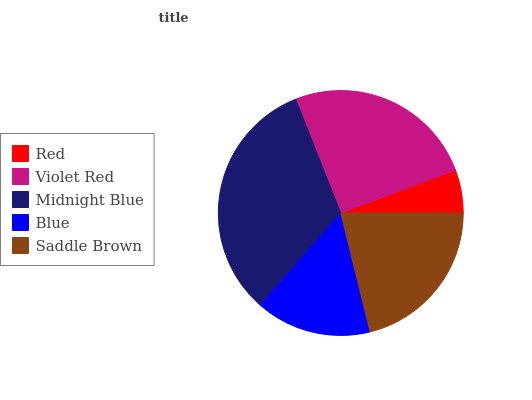Is Red the minimum?
Answer yes or no. Yes. Is Midnight Blue the maximum?
Answer yes or no. Yes. Is Violet Red the minimum?
Answer yes or no. No. Is Violet Red the maximum?
Answer yes or no. No. Is Violet Red greater than Red?
Answer yes or no. Yes. Is Red less than Violet Red?
Answer yes or no. Yes. Is Red greater than Violet Red?
Answer yes or no. No. Is Violet Red less than Red?
Answer yes or no. No. Is Saddle Brown the high median?
Answer yes or no. Yes. Is Saddle Brown the low median?
Answer yes or no. Yes. Is Violet Red the high median?
Answer yes or no. No. Is Red the low median?
Answer yes or no. No. 